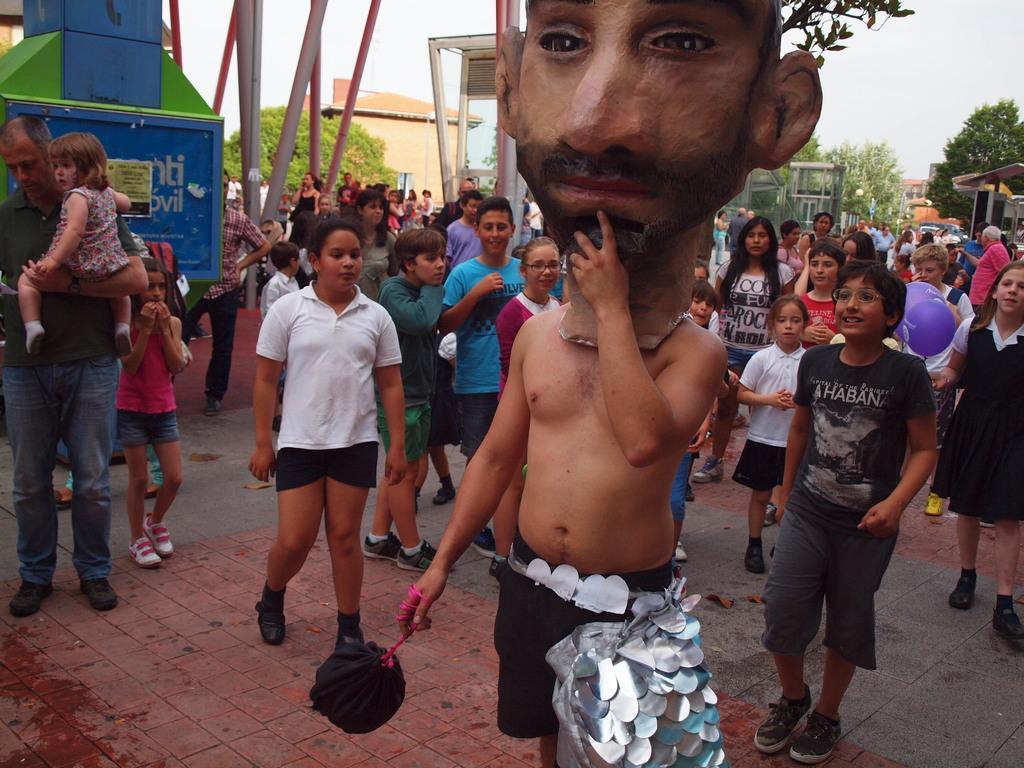Could you give a brief overview of what you see in this image? In this image I can see there are many persons, kids standing and there is a person at right side, he is wearing a mask and there are few trees, buildings and the sky is clear. 